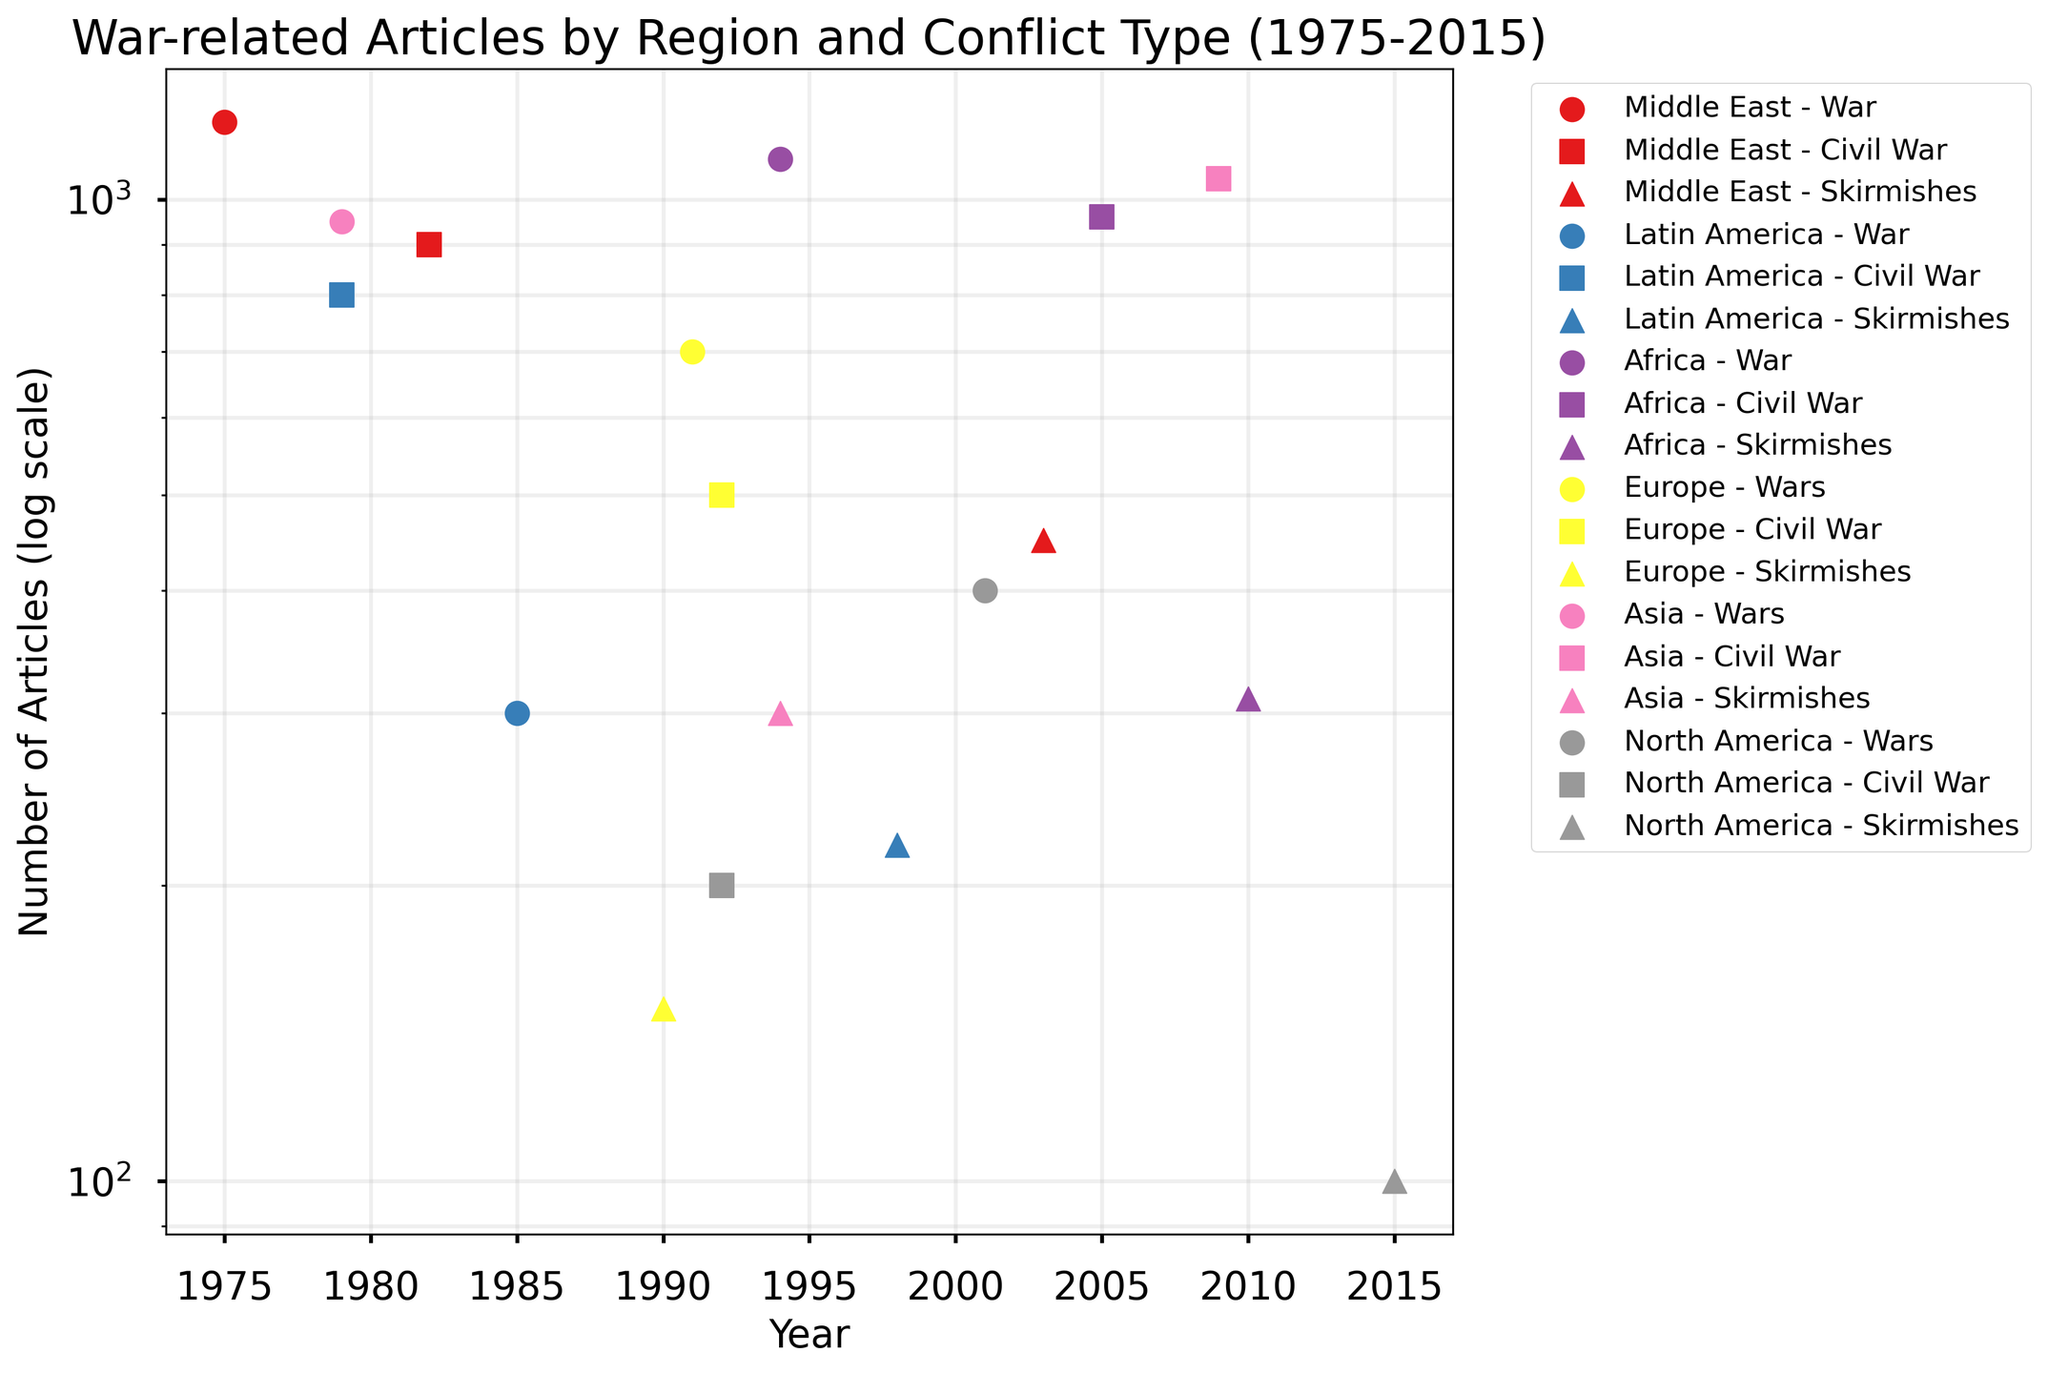What's the title of the scatter plot? The title of the scatter plot can be found at the top of the plot, describing the overall content. It reads "War-related Articles by Region and Conflict Type (1975-2015)".
Answer: War-related Articles by Region and Conflict Type (1975-2015) What does the y-axis represent? The y-axis label is clearly marked and indicates what is being measured. It reads "Number of Articles (log scale)".
Answer: Number of Articles (log scale) How many regions are represented in the scatter plot? The different colors and labels in the legend correspond to the regions. Counting these distinct labels gives us six regions.
Answer: Six What is the highest number of articles published for a single conflict type in a single region, and which region and conflict type does it correspond to? Looking at the y-values (log scale), the highest point is at 1200 articles, corresponding to the Middle East for War in 1975.
Answer: 1200, Middle East, War Which region has the most categories of conflicts mentioned? By counting the number of unique conflict types listed in the legend for each region, we see that each region has all three conflict types (War, Civil War, Skirmishes).
Answer: All regions In which region and year was the number of articles about skirmishes the lowest? Checking the y-values (log scale) specifically for skirmishes across all regions and years, the lowest point corresponds to North America in 2015 with 100 articles.
Answer: North America, 2015 Compare the number of articles published about Wars in Asia in 1979 and Civil Wars in Asia in 2009. Which one had more articles published, and by how much? For Asia, the number of articles in 1979 for Wars is 950 and for Civil Wars in 2009 is 1050. The difference is 1050 - 950 = 100 articles.
Answer: Civil Wars in 2009, by 100 What is the trend of the number of articles about conflicts in Latin America over the years according to the scatter plot? Observing the x-axis (years) for Latin America and reading the y-values (log scale) shows a fluctuating trend with 800 in 1979, 300 in 1985, and 220 in 1998. There appears to be a downward trend.
Answer: Downward trend For which conflict type and year in Africa were articles published in relatively medium numbers (not the highest or lowest)? For Africa, Wars in 1994 had 1100 articles, Civil Wars in 2005 had 960 articles, and Skirmishes in 2010 had 310 articles. The median value here is for Civil Wars in 2005 with 960 articles.
Answer: Civil Wars, 2005 Does any region have articles published about conflicts in years before 1975 or after 2015? The scatter plot data only shows points plotted between 1975 and 2015, indicating no data points exist outside this range for any region.
Answer: No 